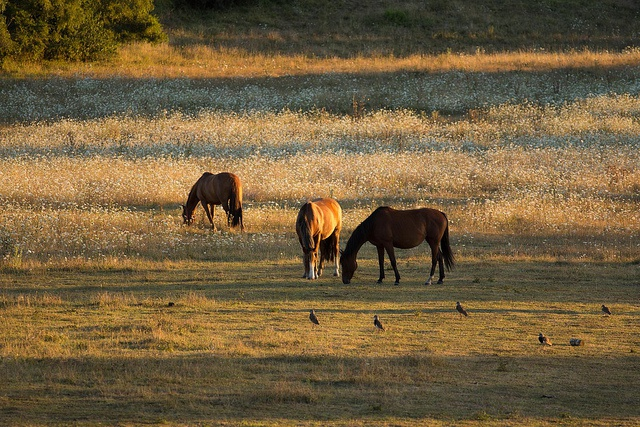Describe the objects in this image and their specific colors. I can see horse in olive, black, maroon, and gray tones, horse in olive, black, orange, and brown tones, horse in olive, black, maroon, brown, and orange tones, bird in olive, black, and gray tones, and bird in olive, black, gray, maroon, and tan tones in this image. 